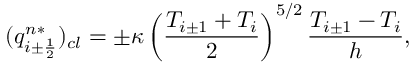Convert formula to latex. <formula><loc_0><loc_0><loc_500><loc_500>( q _ { i \pm \frac { 1 } { 2 } } ^ { n * } ) _ { c l } = \pm \kappa \left ( \frac { T _ { i \pm 1 } + T _ { i } } { 2 } \right ) ^ { 5 / 2 } \frac { T _ { i \pm 1 } - T _ { i } } { h } , \,</formula> 